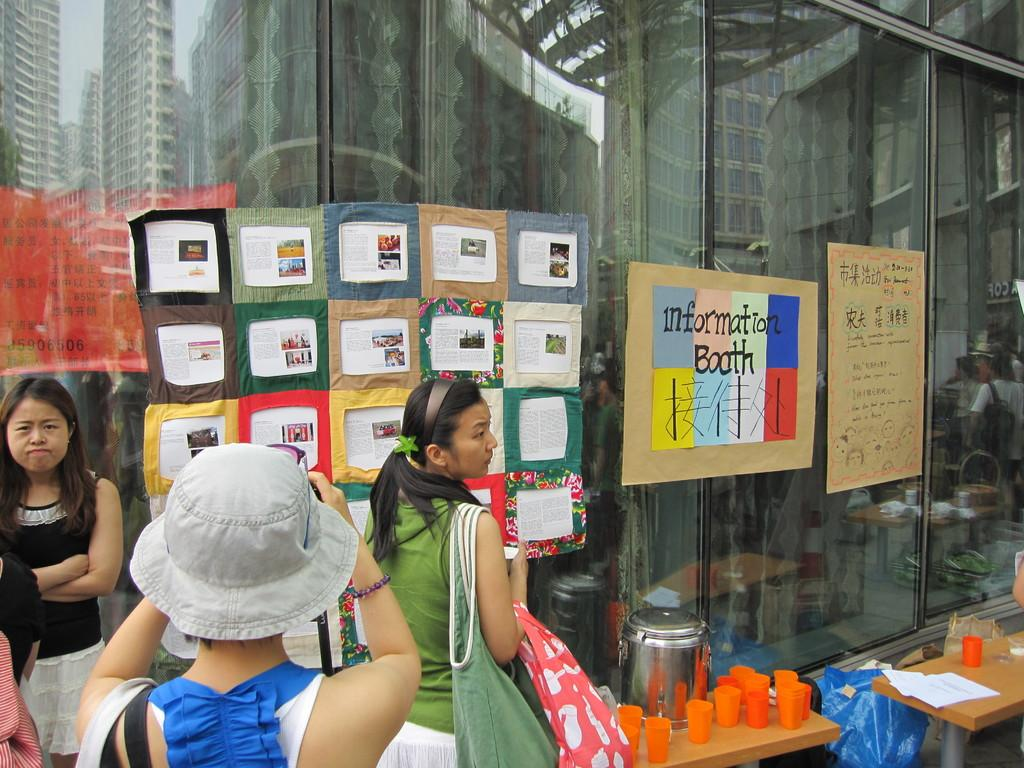What can be seen in the image? There is a group of women in the image. How are the women positioned? The women are standing. What is present on the tables in the image? There are glasses and other objects on the tables. Can you tell me which woman has the longest toe in the image? There is no information about the women's toes in the image, so it cannot be determined which woman has the longest toe. 